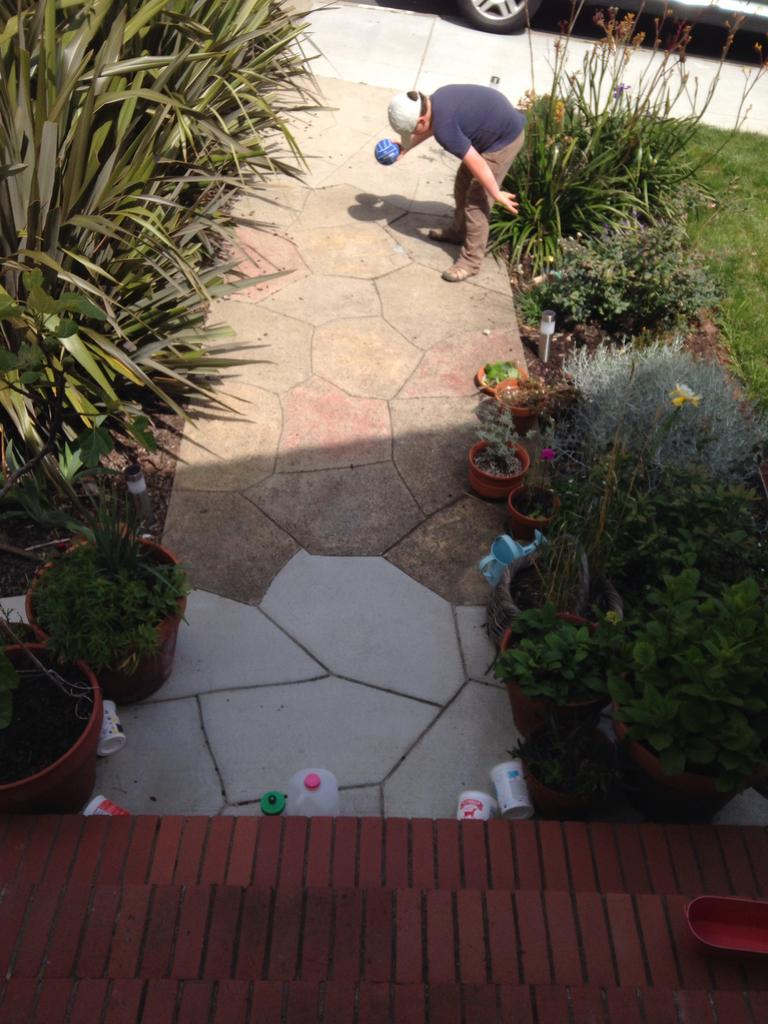Who is in the image? There is a boy in the image. What is the boy holding? The boy is holding a ball. Where is the boy standing? The boy is standing on a path. What type of plants can be seen in the image? There are house plants and trees in the image. What can be seen in the background of the image? There is a vehicle visible in the background of the image. What type of shoes is the yak wearing in the image? There is no yak present in the image, and therefore no shoes to describe. 